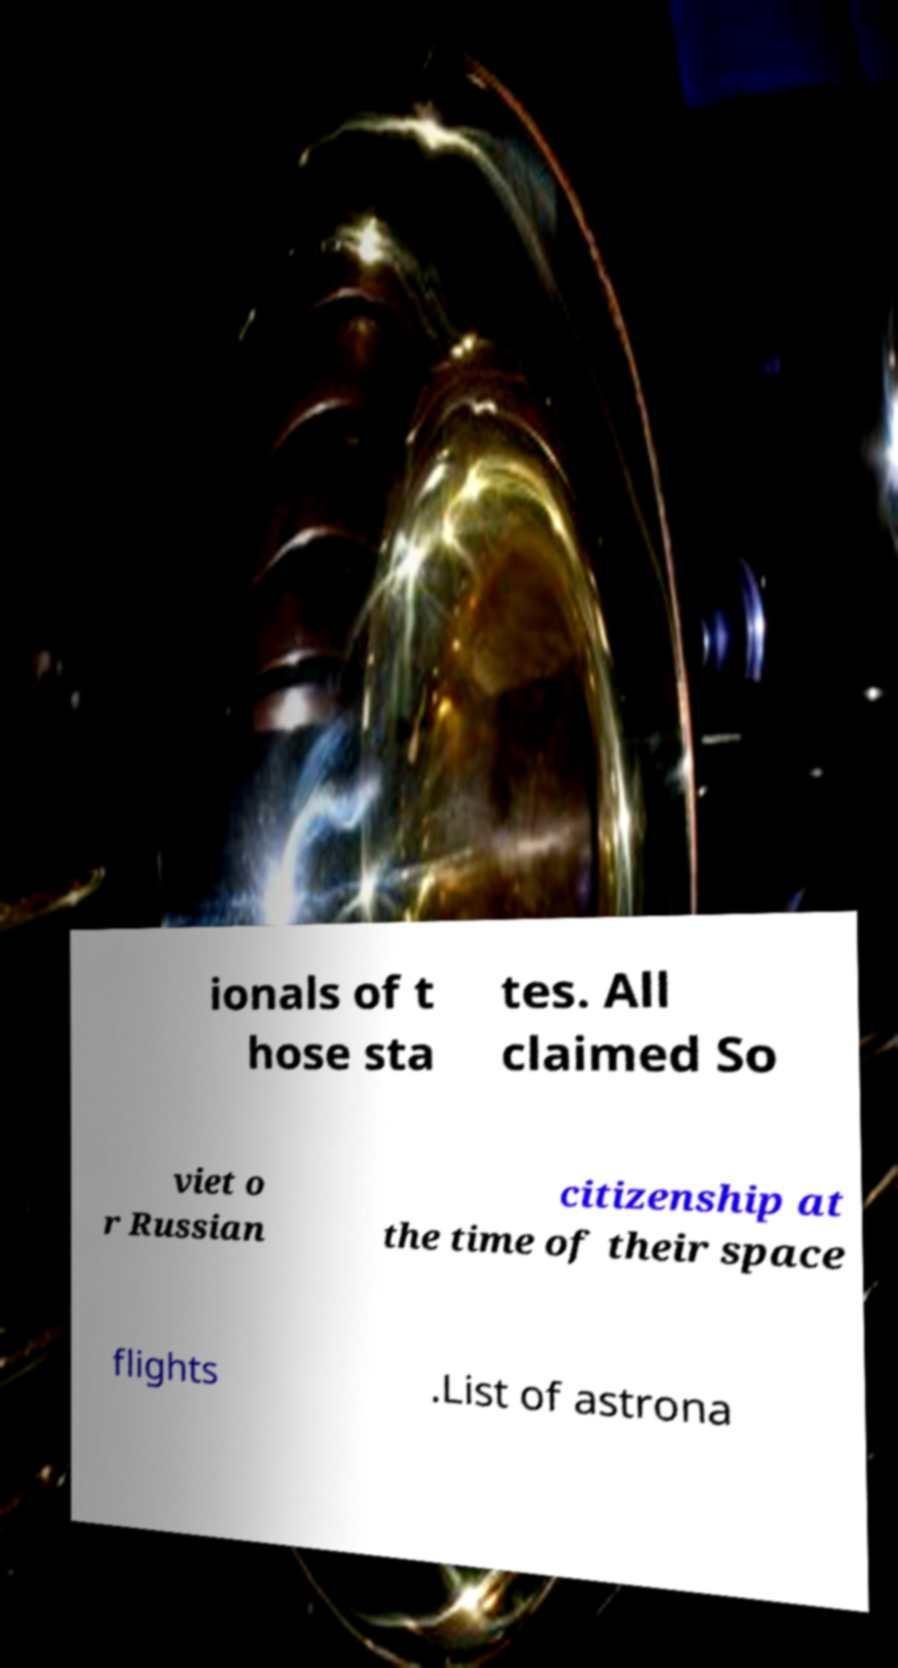Can you read and provide the text displayed in the image?This photo seems to have some interesting text. Can you extract and type it out for me? ionals of t hose sta tes. All claimed So viet o r Russian citizenship at the time of their space flights .List of astrona 